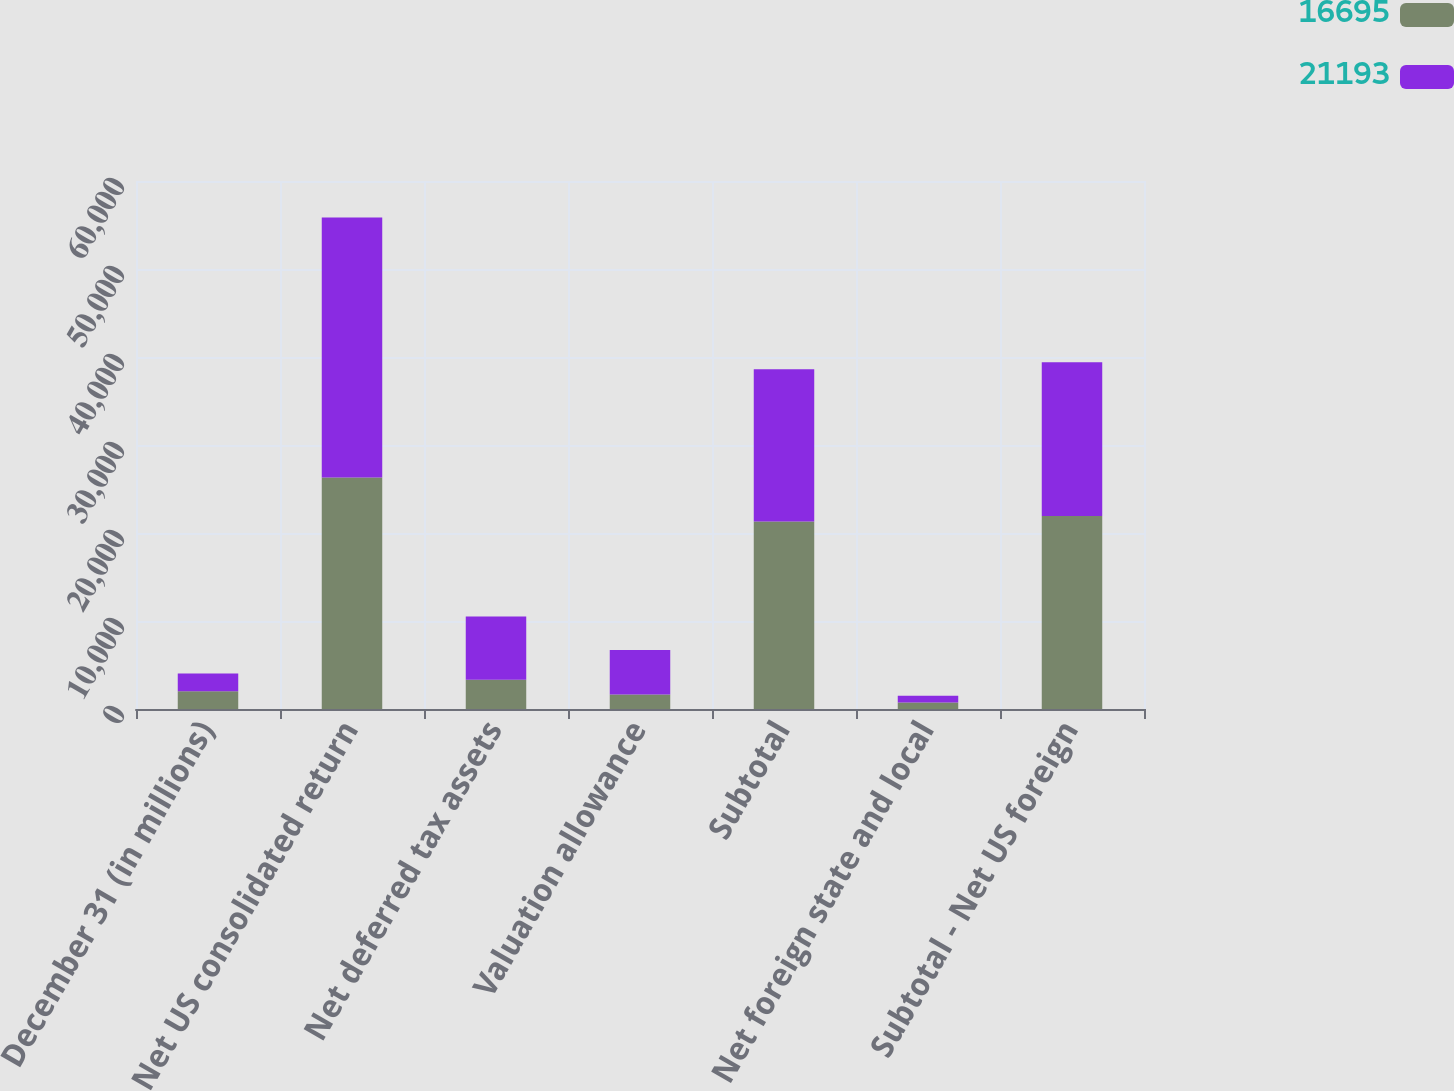Convert chart to OTSL. <chart><loc_0><loc_0><loc_500><loc_500><stacked_bar_chart><ecel><fcel>December 31 (in millions)<fcel>Net US consolidated return<fcel>Net deferred tax assets<fcel>Valuation allowance<fcel>Subtotal<fcel>Net foreign state and local<fcel>Subtotal - Net US foreign<nl><fcel>16695<fcel>2013<fcel>26296<fcel>3337<fcel>1650<fcel>21309<fcel>732<fcel>21925<nl><fcel>21193<fcel>2012<fcel>29550<fcel>7174<fcel>5068<fcel>17308<fcel>771<fcel>17466<nl></chart> 